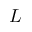<formula> <loc_0><loc_0><loc_500><loc_500>L</formula> 